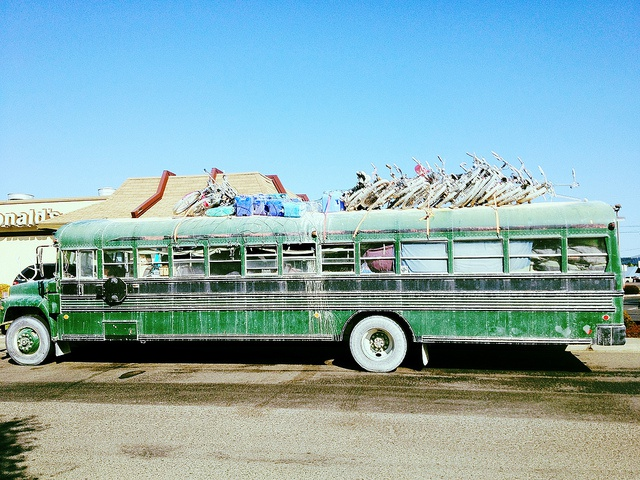Describe the objects in this image and their specific colors. I can see bus in lightblue, lightgray, black, darkgray, and gray tones, bicycle in lightblue, lightgray, darkgray, and black tones, bicycle in lightblue, lightgray, darkgray, and beige tones, bicycle in lightblue, lightgray, darkgray, black, and lightpink tones, and bicycle in lightblue, lightgray, darkgray, black, and gray tones in this image. 